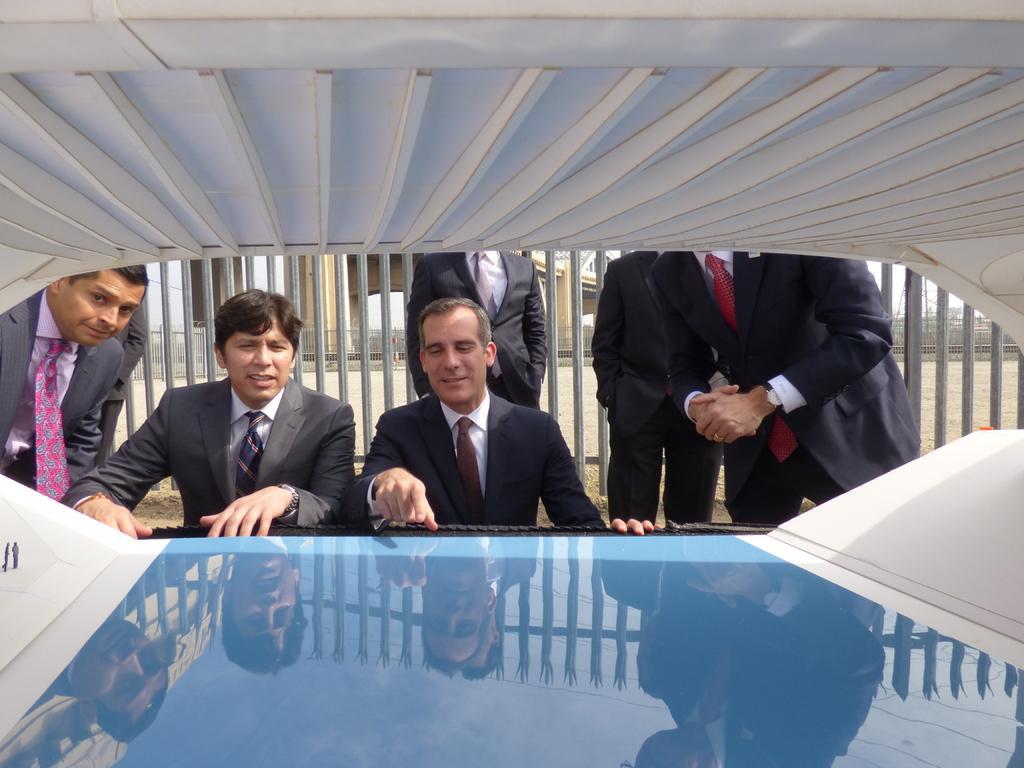Describe this image in one or two sentences. In this picture we can see some people are standing and in front of the people there is an object and behind the people there is an iron fence and other things. 